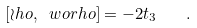<formula> <loc_0><loc_0><loc_500><loc_500>[ \wr h o , \ w o r h o ] = - 2 t _ { 3 } \quad .</formula> 